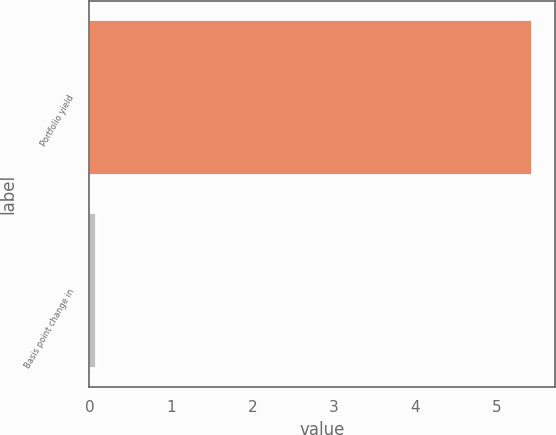Convert chart to OTSL. <chart><loc_0><loc_0><loc_500><loc_500><bar_chart><fcel>Portfolio yield<fcel>Basis point change in<nl><fcel>5.44<fcel>0.08<nl></chart> 